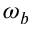<formula> <loc_0><loc_0><loc_500><loc_500>\omega _ { b }</formula> 